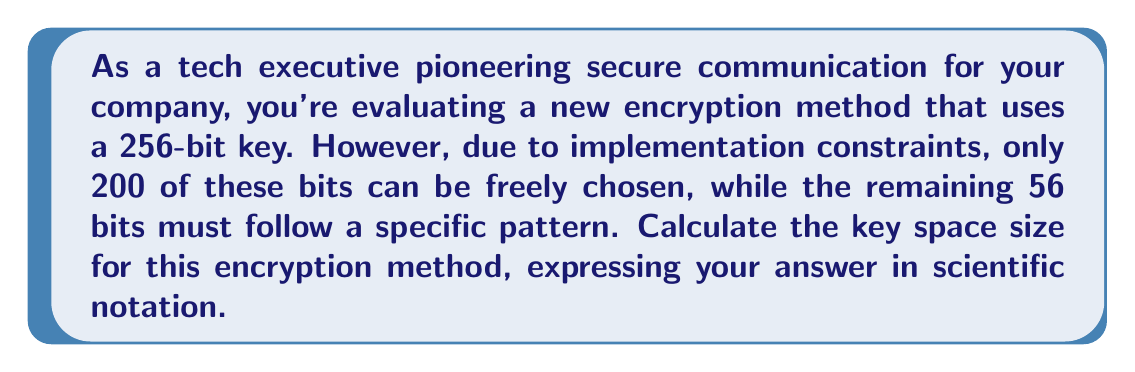What is the answer to this math problem? Let's approach this step-by-step:

1) In a standard 256-bit key, each bit can be either 0 or 1, giving 2 choices for each bit.

2) Normally, the key space size would be $2^{256}$, as there are 2 choices for each of the 256 bits.

3) However, in this case, only 200 bits can be freely chosen, while 56 bits follow a specific pattern.

4) For the 200 freely chosen bits, we have 2 choices for each bit. This gives us $2^{200}$ possibilities.

5) The remaining 56 bits follow a specific pattern, so they don't contribute to the key space size.

6) Therefore, the total key space size is $2^{200}$.

7) To express this in scientific notation:

   $2^{200} = 2^{200} \times 10^0$
   
   $= (2^{10})^{20} \times 10^0$
   
   $\approx (1.024 \times 10^3)^{20} \times 10^0$
   
   $\approx 1.024^{20} \times 10^{60}$
   
   $\approx 1.6069 \times 10^{60}$

8) Rounding to 4 significant figures, we get $1.607 \times 10^{60}$.
Answer: $1.607 \times 10^{60}$ 